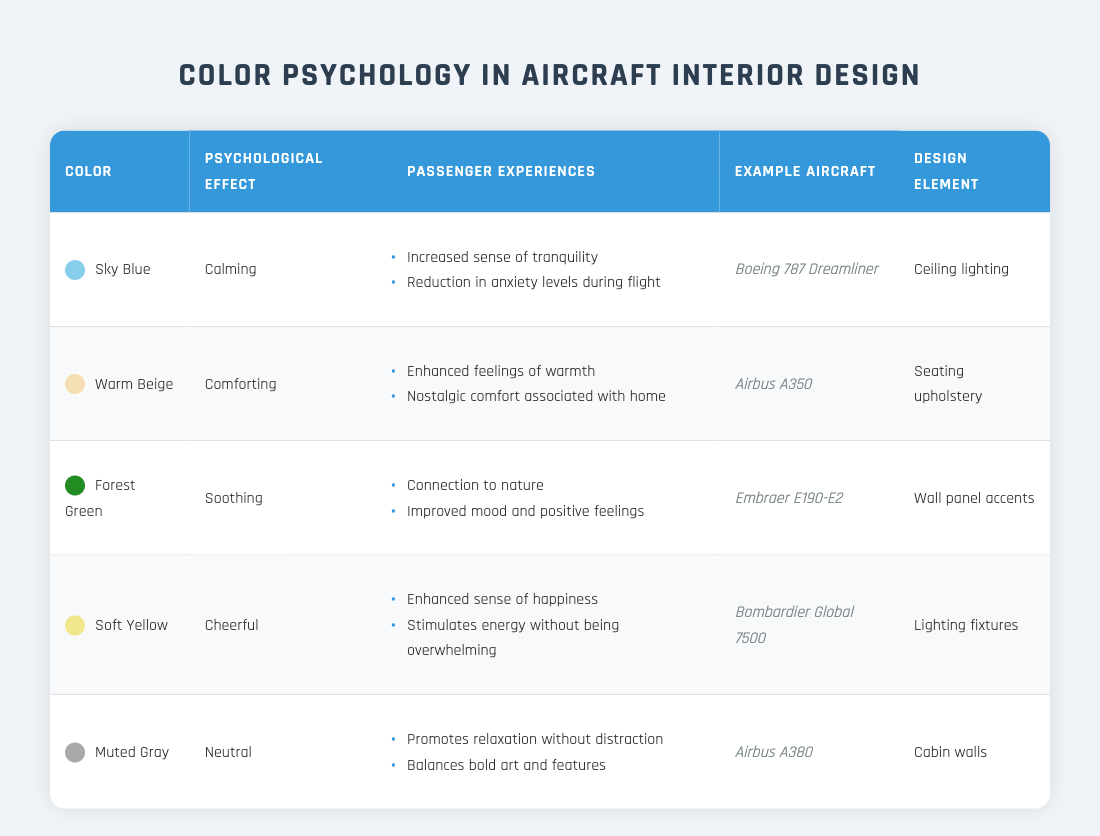What psychological effect is associated with Sky Blue? The table lists "Sky Blue" under the "Color" column, and its corresponding psychological effect is stated in the adjacent column as "Calming."
Answer: Calming Which aircraft uses Warm Beige in its seating upholstery? The table indicates that "Warm Beige" is used in "Seating upholstery" and lists "Airbus A350" as the example aircraft in the adjacent column.
Answer: Airbus A350 True or False: Forest Green is associated with an increase in anxiety levels during flight. The table describes the psychological effect of "Forest Green" as "Soothing," which is linked to improved mood and positive feelings, implying it does not increase anxiety levels.
Answer: False What are the passenger experiences related to Soft Yellow? For "Soft Yellow," the table lists its passenger experiences, which include "Enhanced sense of happiness" and "Stimulates energy without being overwhelming."
Answer: Enhanced sense of happiness, Stimulates energy without being overwhelming Which color is linked to a neutral psychological effect? The table shows "Muted Gray" associated with a "Neutral" psychological effect, as noted in the respective column.
Answer: Muted Gray Calculate the total number of passenger experiences across all colors listed. By looking at the table, each color has 2 passenger experiences listed. With 5 colors total, the calculation is 5 colors multiplied by 2 experiences each, equaling 10.
Answer: 10 Which design element is used for the lighting in the Boeing 787 Dreamliner? Referring to the table, the "Boeing 787 Dreamliner" appears under the "Example Aircraft" column with "Ceiling lighting" mentioned in the "Design Element" column, indicating the use of ceiling lighting for this aircraft.
Answer: Ceiling lighting True or False: The psychological effect of Warm Beige is described as soothing. According to the table, the psychological effect of "Warm Beige" is listed as "Comforting," which is not the same as "Soothing," making the statement false.
Answer: False What is the common theme among the psychological effects described for the colors listed? Upon reviewing the psychological effects for all listed colors, they generally aim to enhance comfort, tranquility, and positive feelings, suggesting that a common theme is the enhancement of the overall passenger experience during flight.
Answer: Enhancement of comfort and positivity 